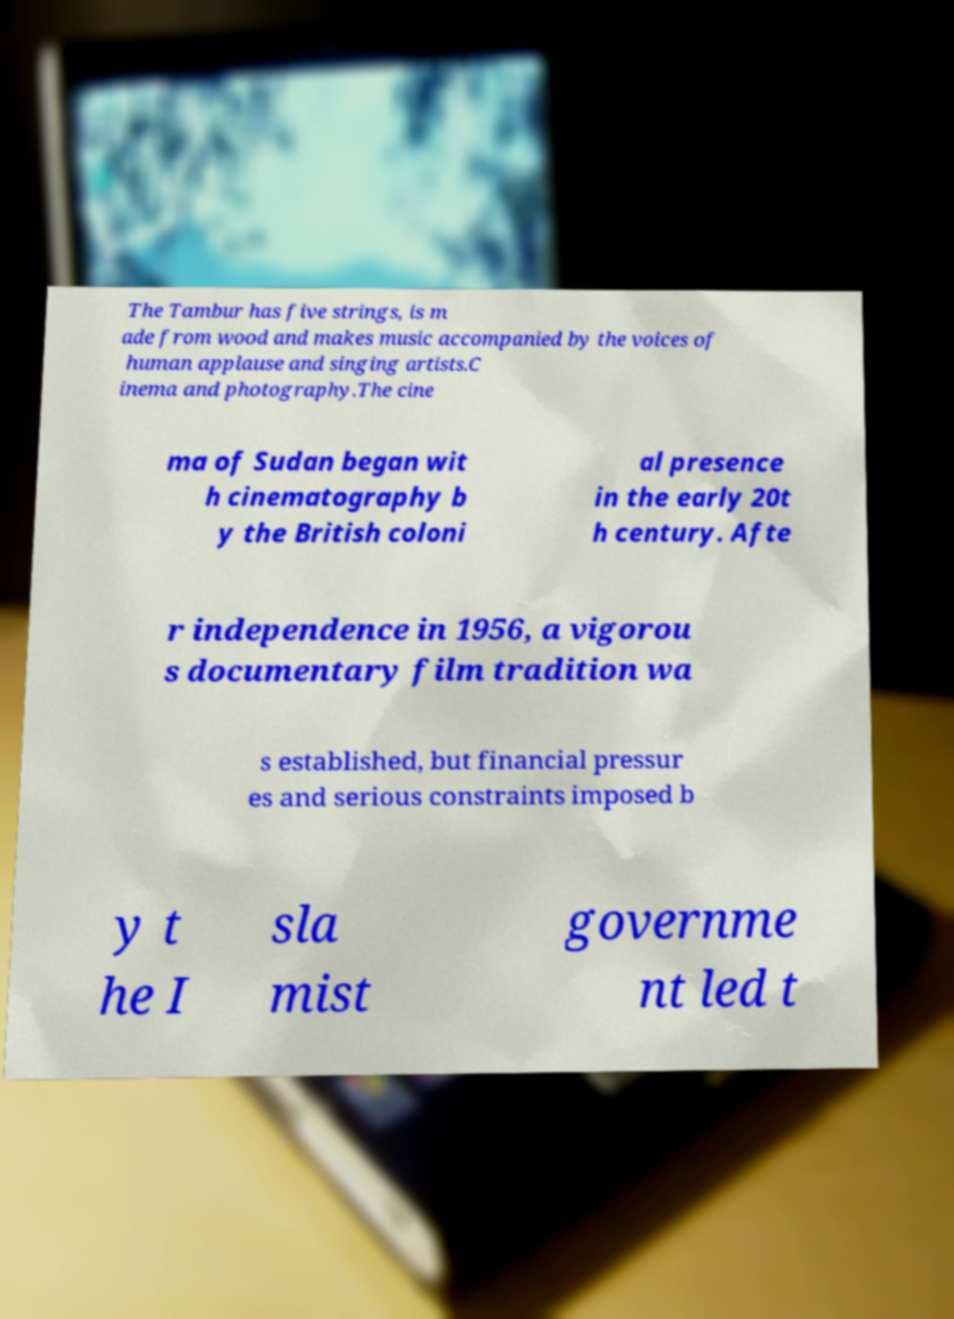What messages or text are displayed in this image? I need them in a readable, typed format. The Tambur has five strings, is m ade from wood and makes music accompanied by the voices of human applause and singing artists.C inema and photography.The cine ma of Sudan began wit h cinematography b y the British coloni al presence in the early 20t h century. Afte r independence in 1956, a vigorou s documentary film tradition wa s established, but financial pressur es and serious constraints imposed b y t he I sla mist governme nt led t 